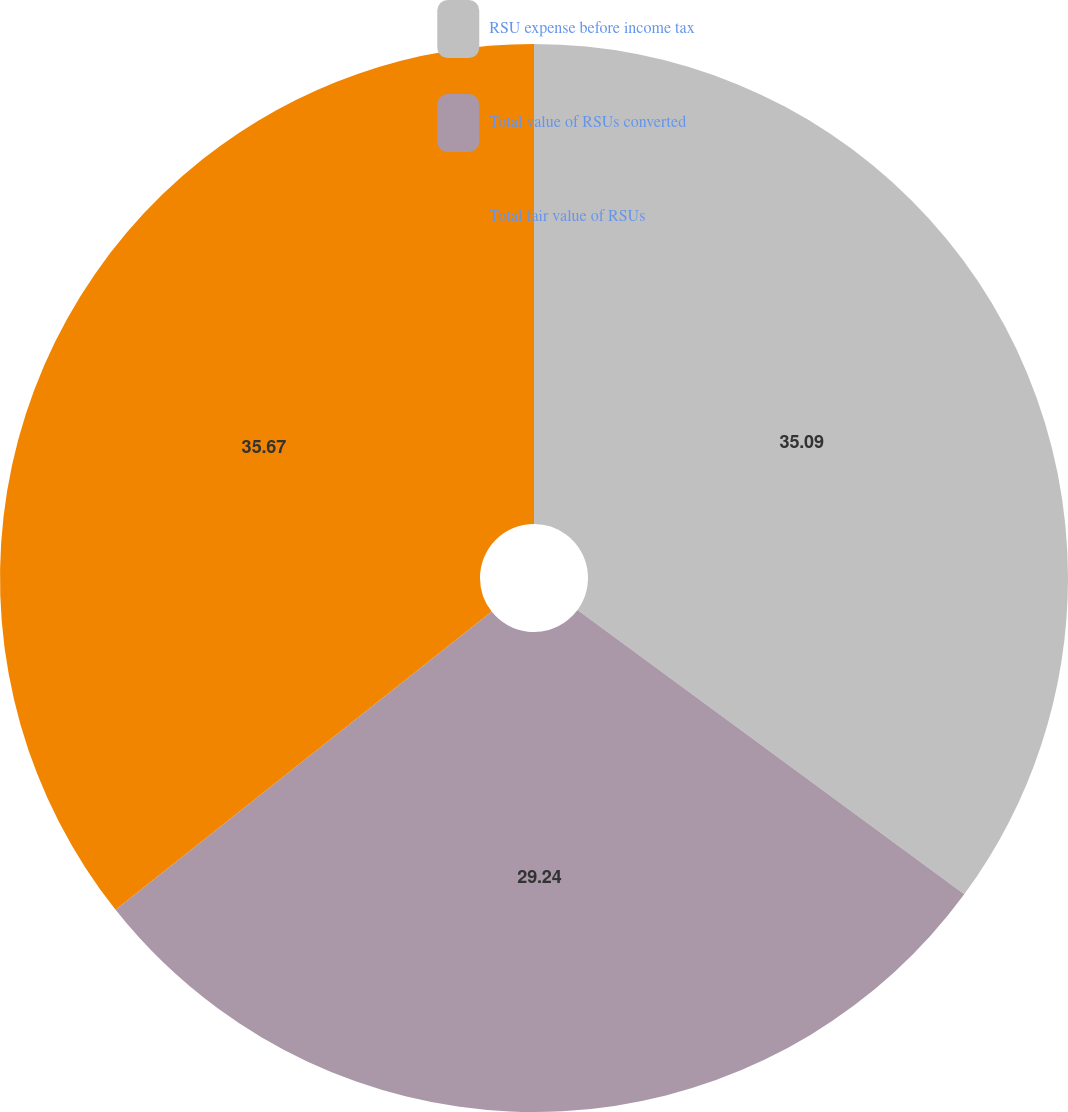Convert chart. <chart><loc_0><loc_0><loc_500><loc_500><pie_chart><fcel>RSU expense before income tax<fcel>Total value of RSUs converted<fcel>Total fair value of RSUs<nl><fcel>35.09%<fcel>29.24%<fcel>35.67%<nl></chart> 